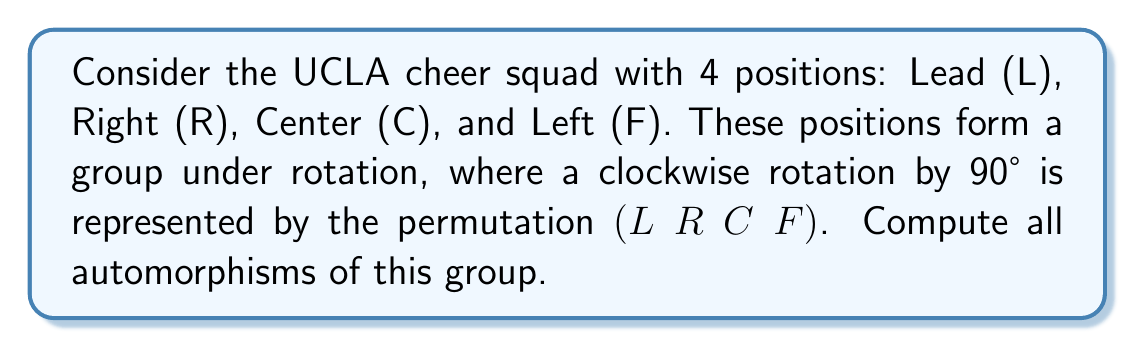Give your solution to this math problem. Let's approach this step-by-step:

1) First, we need to understand the group structure. This group is isomorphic to the cyclic group $C_4$, generated by the 90° rotation $r = (L\;R\;C\;F)$.

2) The elements of the group are:
   $e = ()$ (identity)
   $r = (L\;R\;C\;F)$ (90° rotation)
   $r^2 = (L\;C)(R\;F)$ (180° rotation)
   $r^3 = (L\;F\;C\;R)$ (270° rotation)

3) An automorphism $\phi$ of this group must map the generator $r$ to another generator of the group. The only generators are $r$ and $r^3$.

4) If $\phi(r) = r$, then $\phi$ is the identity automorphism.

5) If $\phi(r) = r^3$, then:
   $\phi(e) = e$
   $\phi(r) = r^3$
   $\phi(r^2) = (r^3)^2 = r^2$
   $\phi(r^3) = (r^3)^3 = r$

6) We can verify that this is indeed an automorphism:
   $\phi(r \cdot r) = \phi(r^2) = r^2 = r^3 \cdot r^3 = \phi(r) \cdot \phi(r)$

7) Therefore, there are exactly two automorphisms of this group:
   - The identity automorphism
   - The automorphism that maps $r$ to $r^3$

In terms of the cheer positions:
- The identity automorphism keeps all positions the same.
- The non-identity automorphism swaps Right with Left, keeping Lead and Center fixed.
Answer: The group has exactly 2 automorphisms:
1) The identity automorphism: $\phi_1(r) = r$
2) The automorphism defined by: $\phi_2(r) = r^3$ 